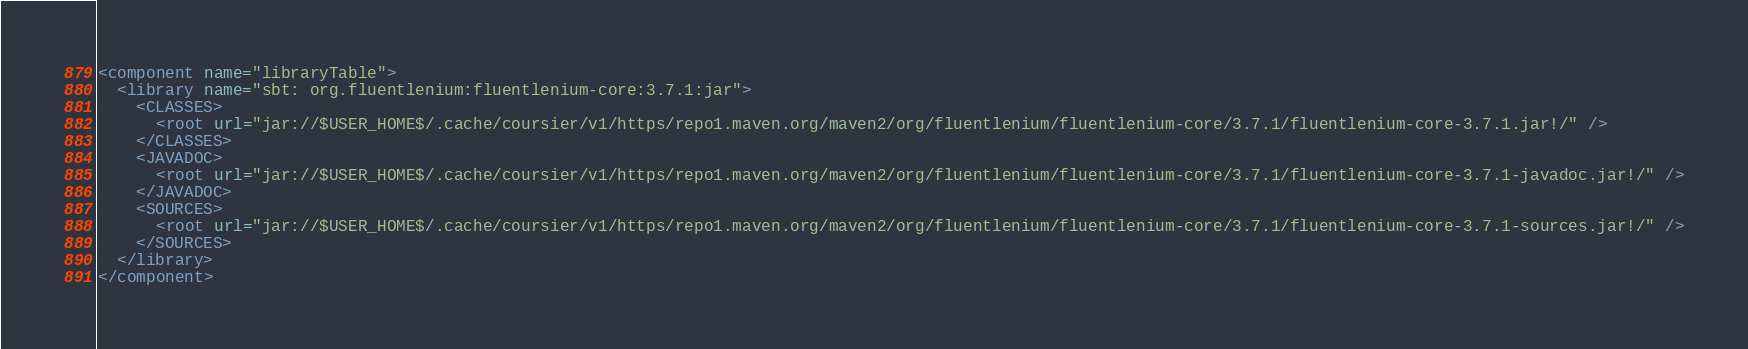Convert code to text. <code><loc_0><loc_0><loc_500><loc_500><_XML_><component name="libraryTable">
  <library name="sbt: org.fluentlenium:fluentlenium-core:3.7.1:jar">
    <CLASSES>
      <root url="jar://$USER_HOME$/.cache/coursier/v1/https/repo1.maven.org/maven2/org/fluentlenium/fluentlenium-core/3.7.1/fluentlenium-core-3.7.1.jar!/" />
    </CLASSES>
    <JAVADOC>
      <root url="jar://$USER_HOME$/.cache/coursier/v1/https/repo1.maven.org/maven2/org/fluentlenium/fluentlenium-core/3.7.1/fluentlenium-core-3.7.1-javadoc.jar!/" />
    </JAVADOC>
    <SOURCES>
      <root url="jar://$USER_HOME$/.cache/coursier/v1/https/repo1.maven.org/maven2/org/fluentlenium/fluentlenium-core/3.7.1/fluentlenium-core-3.7.1-sources.jar!/" />
    </SOURCES>
  </library>
</component></code> 